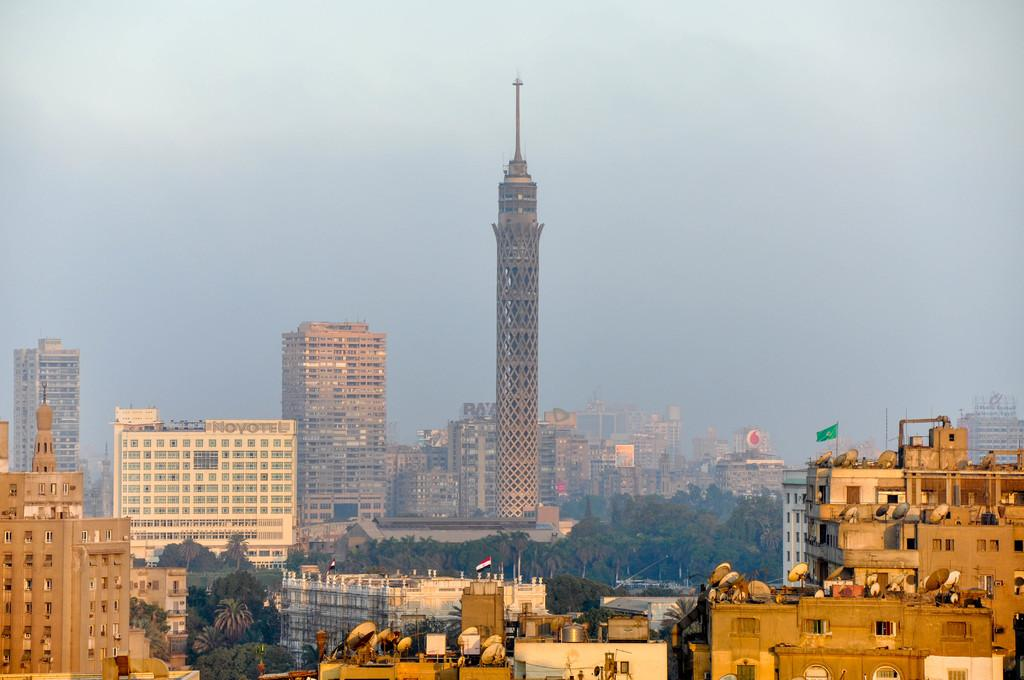What type of structures are present in the image? The image contains buildings and skyscrapers. Can you describe the flag in the image? There is a flag on a building on the right side of the image. What is visible at the top of the image? The sky is visible at the top of the image. What type of vegetation can be seen at the bottom of the image? Trees are present at the bottom of the image. What type of egg is being used to comb the trees in the image? There is no egg or comb present in the image; it features buildings, skyscrapers, a flag, the sky, and trees. 